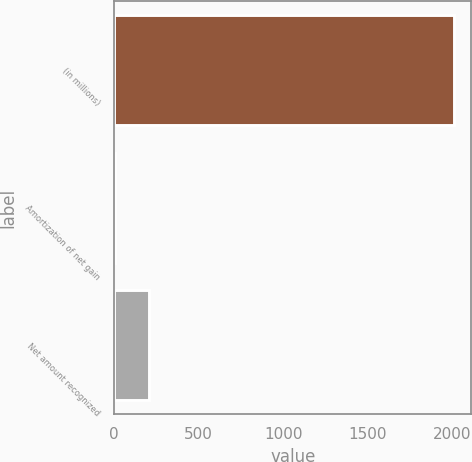<chart> <loc_0><loc_0><loc_500><loc_500><bar_chart><fcel>(in millions)<fcel>Amortization of net gain<fcel>Net amount recognized<nl><fcel>2014<fcel>7<fcel>207.7<nl></chart> 